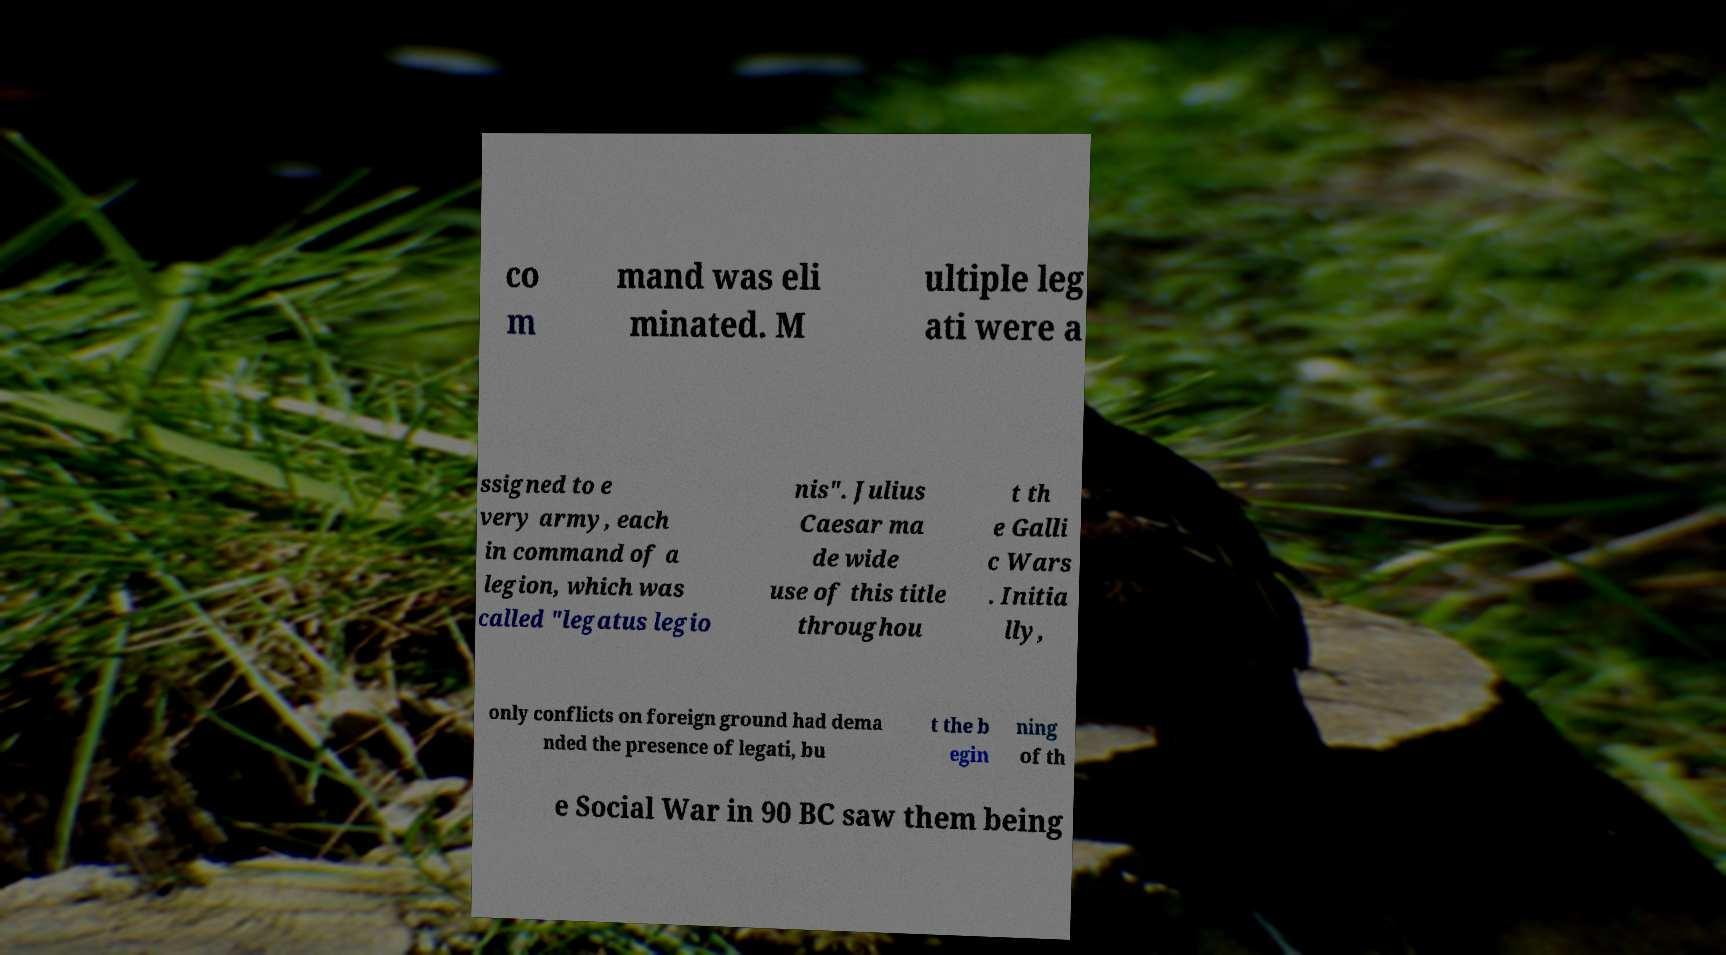There's text embedded in this image that I need extracted. Can you transcribe it verbatim? co m mand was eli minated. M ultiple leg ati were a ssigned to e very army, each in command of a legion, which was called "legatus legio nis". Julius Caesar ma de wide use of this title throughou t th e Galli c Wars . Initia lly, only conflicts on foreign ground had dema nded the presence of legati, bu t the b egin ning of th e Social War in 90 BC saw them being 